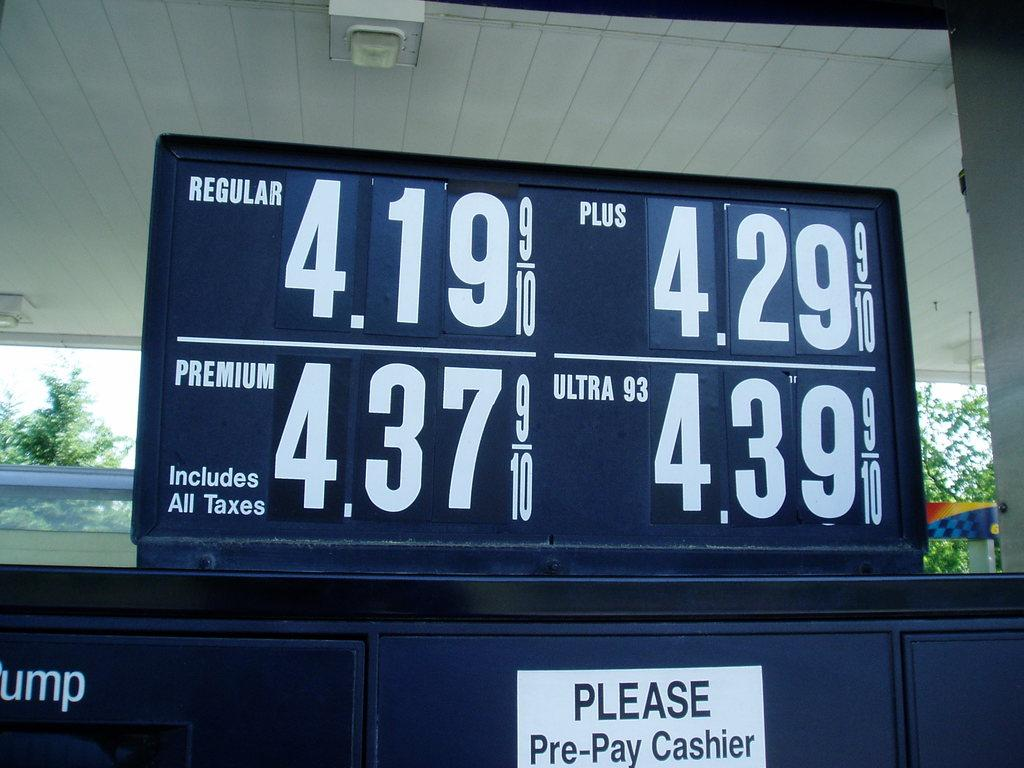<image>
Write a terse but informative summary of the picture. A price sign for gas in a station stating that you must Pre-Pay the cashier before pumping. 